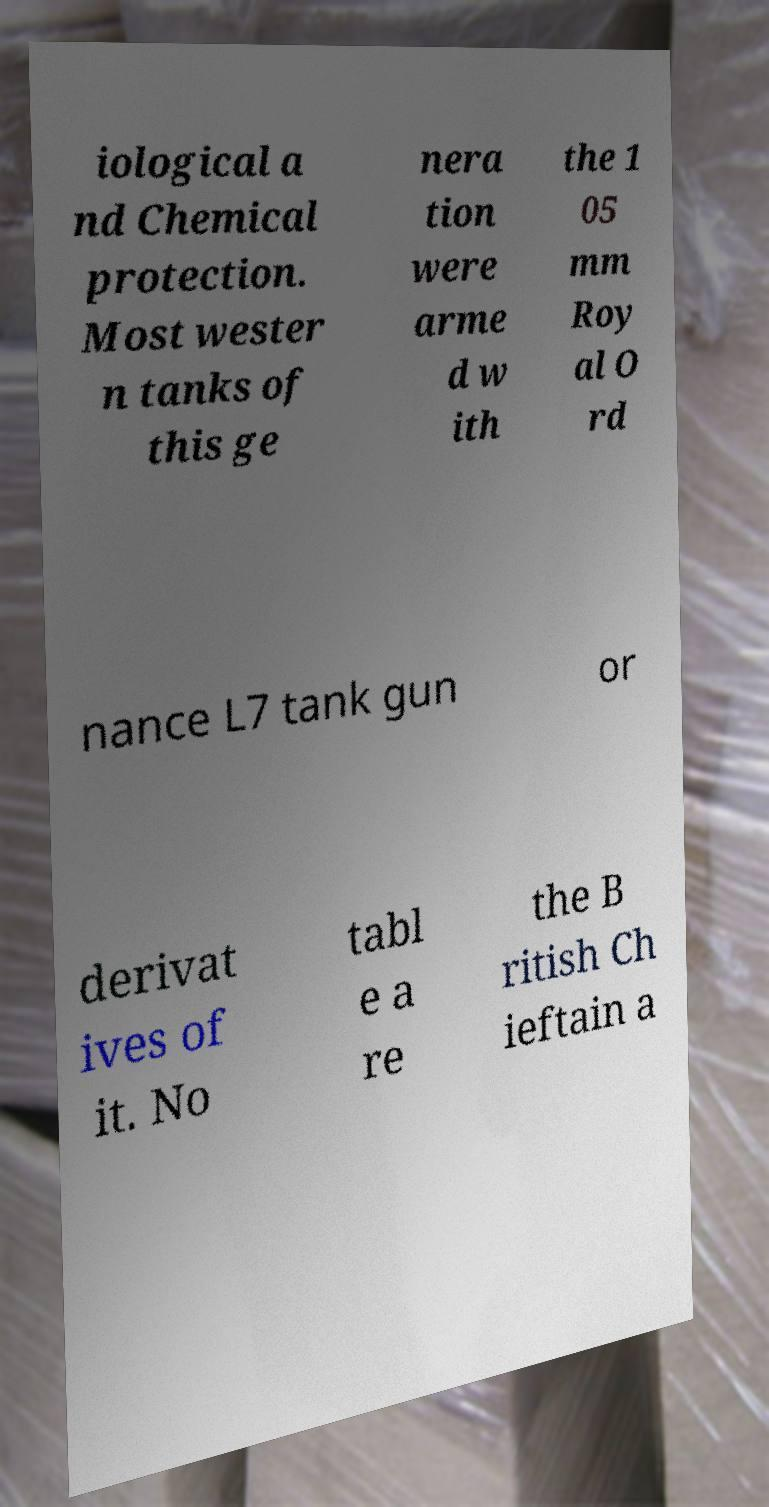Please read and relay the text visible in this image. What does it say? iological a nd Chemical protection. Most wester n tanks of this ge nera tion were arme d w ith the 1 05 mm Roy al O rd nance L7 tank gun or derivat ives of it. No tabl e a re the B ritish Ch ieftain a 